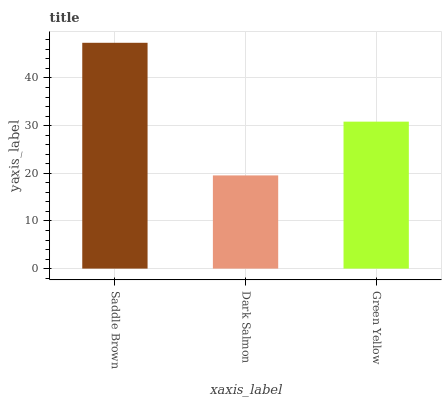Is Dark Salmon the minimum?
Answer yes or no. Yes. Is Saddle Brown the maximum?
Answer yes or no. Yes. Is Green Yellow the minimum?
Answer yes or no. No. Is Green Yellow the maximum?
Answer yes or no. No. Is Green Yellow greater than Dark Salmon?
Answer yes or no. Yes. Is Dark Salmon less than Green Yellow?
Answer yes or no. Yes. Is Dark Salmon greater than Green Yellow?
Answer yes or no. No. Is Green Yellow less than Dark Salmon?
Answer yes or no. No. Is Green Yellow the high median?
Answer yes or no. Yes. Is Green Yellow the low median?
Answer yes or no. Yes. Is Dark Salmon the high median?
Answer yes or no. No. Is Dark Salmon the low median?
Answer yes or no. No. 